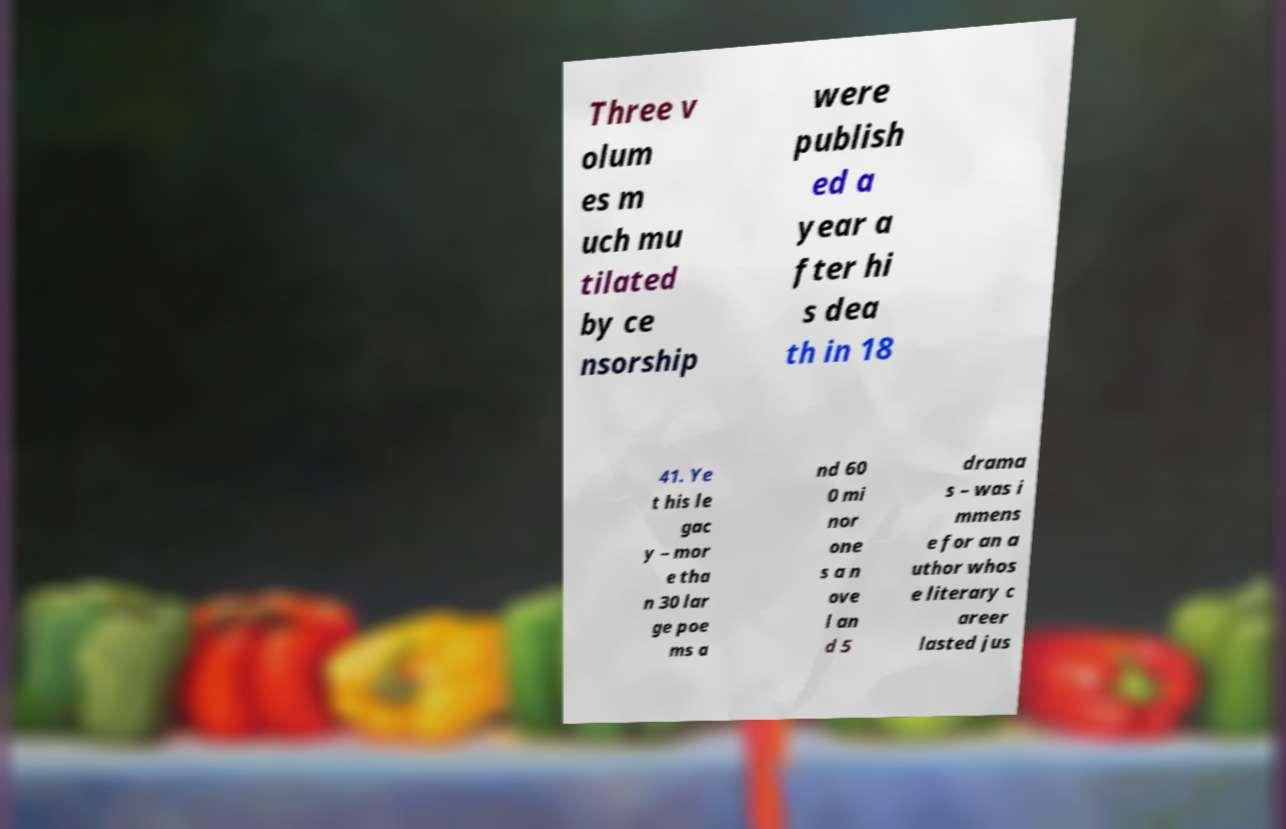I need the written content from this picture converted into text. Can you do that? Three v olum es m uch mu tilated by ce nsorship were publish ed a year a fter hi s dea th in 18 41. Ye t his le gac y – mor e tha n 30 lar ge poe ms a nd 60 0 mi nor one s a n ove l an d 5 drama s – was i mmens e for an a uthor whos e literary c areer lasted jus 